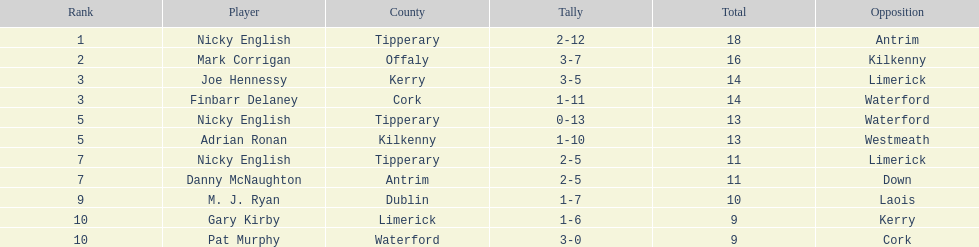What is the initial name present on the list? Nicky English. 